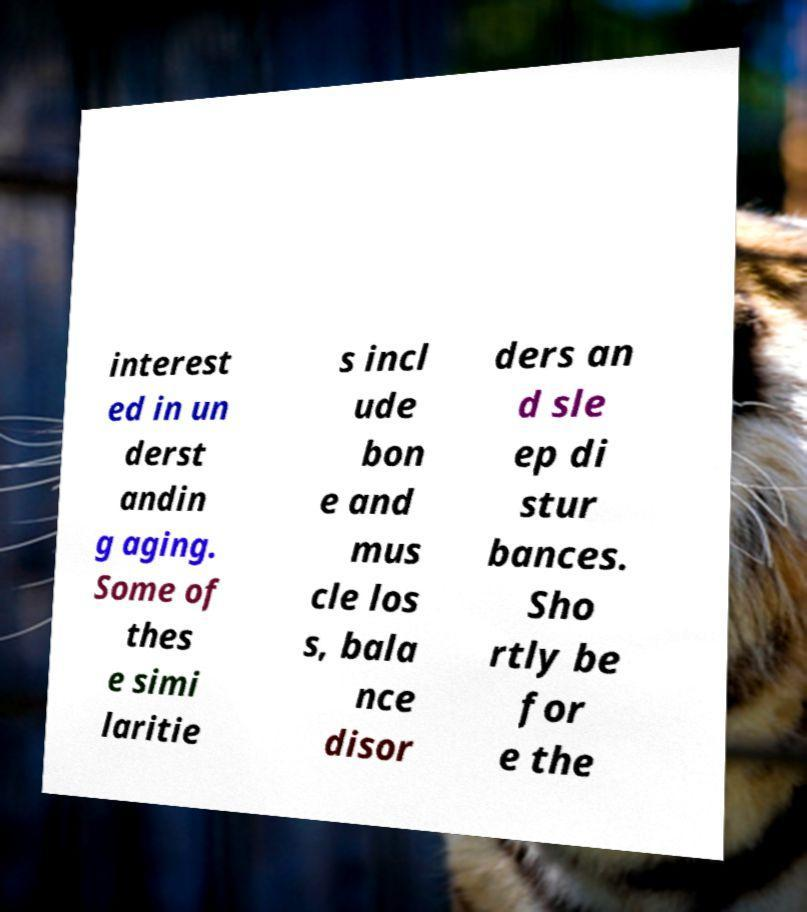What messages or text are displayed in this image? I need them in a readable, typed format. interest ed in un derst andin g aging. Some of thes e simi laritie s incl ude bon e and mus cle los s, bala nce disor ders an d sle ep di stur bances. Sho rtly be for e the 